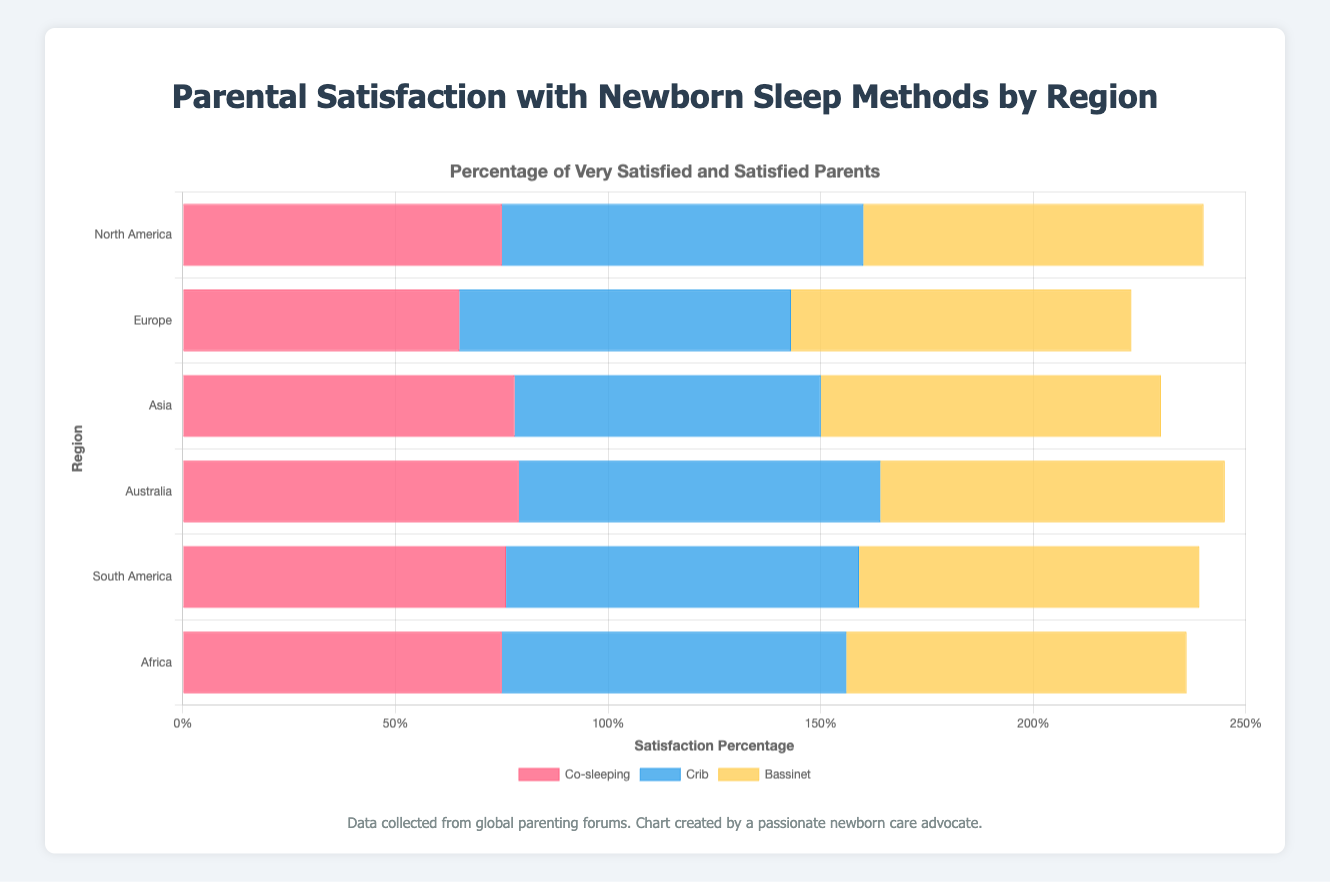Which region reported the highest combined percentage of Very Satisfied and Satisfied parents for Crib sleep method? North America has 50 + 35 = 85% Very Satisfied + Satisfied for Crib, Europe has 48 + 30 = 78%, Asia has 42 + 30 = 72%, Australia has 51 + 34 = 85%, South America has 47 + 36 = 83%, and Africa has 46 + 35 = 81%. By comparing all regions, North America and Australia both reported the highest percentage of 85%.
Answer: North America and Australia Which sleep method has the highest average satisfaction across all regions? For Co-sleeping, calculate the average of Very Satisfied and Satisfied combined: (45+30+40+25+50+28+47+32+43+33+44+31) / 6 = (75 + 65 + 78 + 79 + 76 + 75) / 6 = 73%. For Crib: (50+35+48+30+42+30+51+34+47+36+46+35) / 6 = (85 + 78 + 72 + 85 + 83 + 81) / 6 = 80.67%. For Bassinet: (40+40+35+45+37+43+39+42+36+44+38+42) / 6 = (80 + 80 + 80 + 81 + 80 + 80) / 6 = 80.17%. Crib has the highest average satisfaction with 80.67%.
Answer: Crib Which method has the greatest variability in satisfaction across regions (based on the range of Very Satisfied percentages)? For Co-sleeping, the range is 50 (Asia) - 40 (Europe) = 10. For Crib, the range is 51 (Australia) - 42 (Asia) = 9. For Bassinet, the range is 40 (North America) - 35 (Europe) = 5. Co-sleeping has the greatest range of 10.
Answer: Co-sleeping Which region has the lowest percentage of Unsatisfied parents regardless of the sleep method? Sum up and compare the Unsatisfied percentages across sleep methods per region. North America (8+5+7), Europe (12+6+5), Asia (6+8+5), Australia (6+5+6), South America (7+4+4), Africa (7+5+5). North America: 20, Europe: 23, Asia: 19, Australia: 17, South America: 15, Africa: 17. South America has the lowest combined Unsatisfied percentage.
Answer: South America What is the total percentage of Neutral or Unsatisfied parents for the Bassinet method in Europe? Neutral (12) + Unsatisfied (5) = 17%
Answer: 17% Which region has the most even distribution of parental satisfaction levels for Co-sleeping? Check the differences between Very Satisfied, Satisfied, Neutral, Unsatisfied, and Very Unsatisfied for each region. North America (45-30-10-8-7), Europe (40-25-15-12-8), Asia (50-28-12-6-4), Australia (47-32-11-6-4), South America (43-33-12-7-5), Africa (44-31-13-7-5). Europe (15-10-3-4) has the smallest differences, showing the most even distribution.
Answer: Europe Which sleep method in Asia has the lowest percentage of Neutral or lower rating? Co-sleeping: Neutral (12) + Unsatisfied (6) + Very Unsatisfied (4) = 22%, Crib: Neutral (15) + Unsatisfied (8) + Very Unsatisfied (5) = 28%, Bassinet: Neutral (13) + Unsatisfied (5) + Very Unsatisfied (2) = 20%. Bassinet has the lowest combined percentage of Neutral or lower at 20%.
Answer: Bassinet 